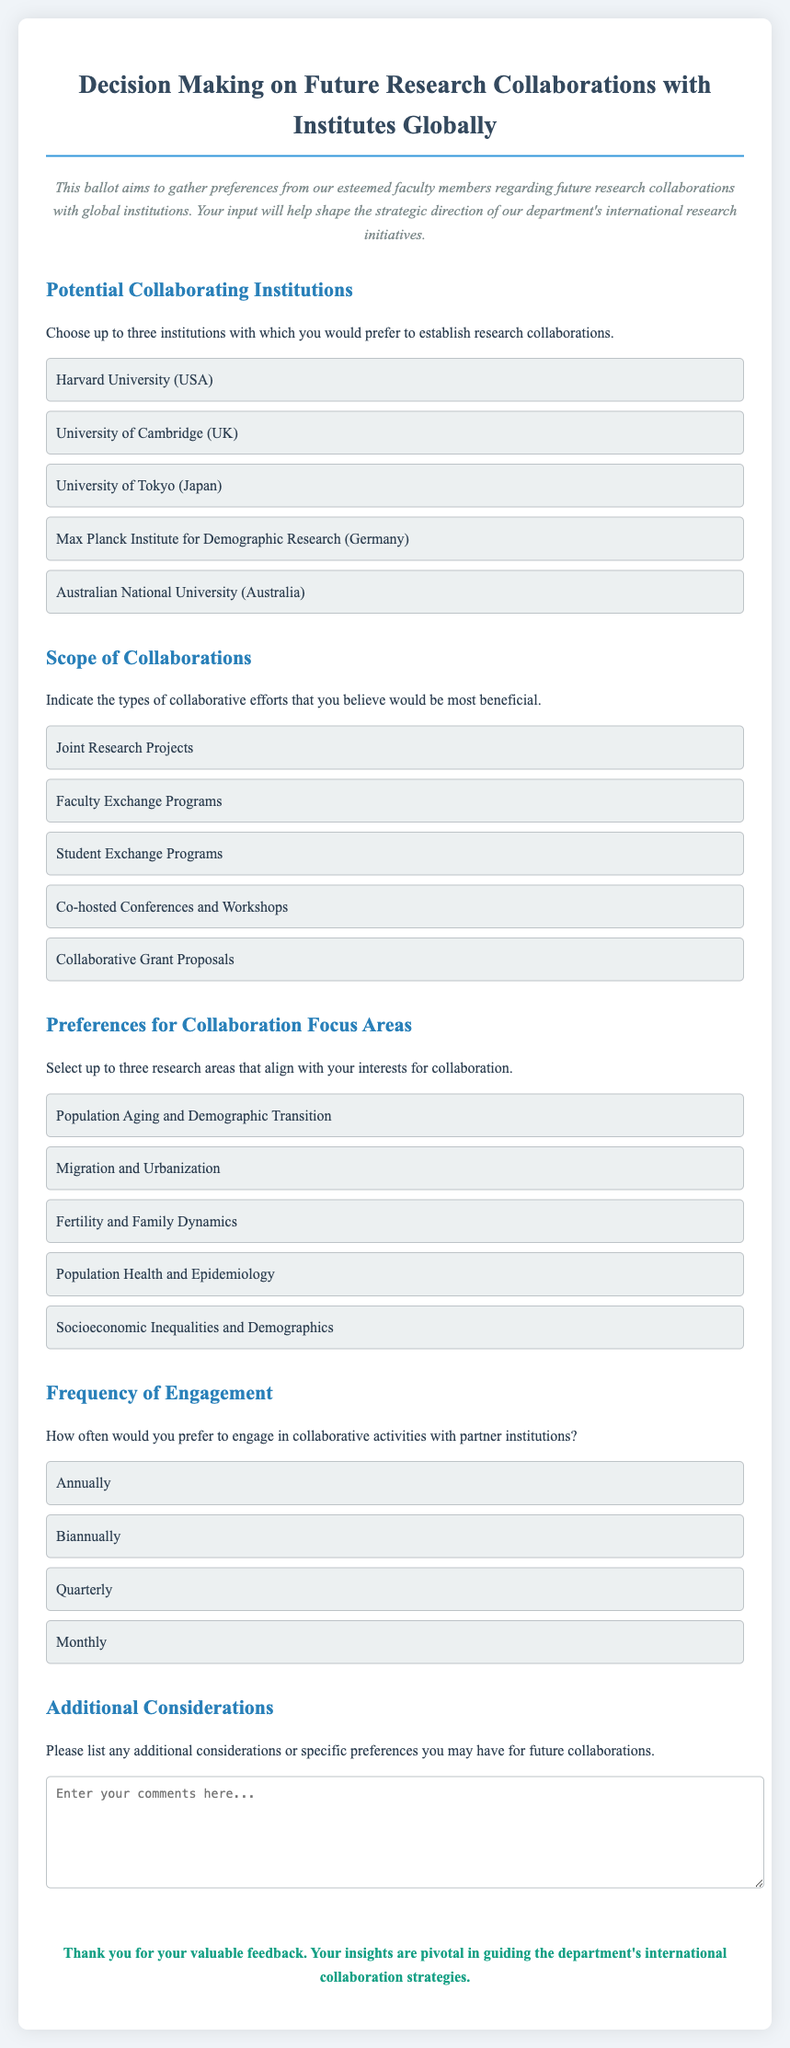What is the title of the ballot? The title is explicitly stated at the beginning of the document, indicating the purpose of the ballot regarding research collaborations.
Answer: Decision Making on Future Research Collaborations with Institutes Globally How many institutions can faculty members choose for collaboration? The document specifies that faculty members can select up to three institutions to express their preference for collaboration.
Answer: Three Which institution is listed as a collaboration option in Japan? The document includes a list of institutions for potential collaboration, one of which is based in Japan.
Answer: University of Tokyo What type of collaborative effort is proposed for co-hosted events? The document discusses various types of collaboration, including specific efforts involving events that can be co-hosted.
Answer: Co-hosted Conferences and Workshops What research area focuses on demographic transitions? Among the research areas listed for faculty collaboration preferences, one is explicitly related to demographic transitions and aging.
Answer: Population Aging and Demographic Transition Which frequency of engagement option is available for faculty preference? The document provides multiple timeframes for how often faculty wish to engage in collaborations, one of which is specified.
Answer: Biannually What is the purpose of the additional considerations section? The document asks faculty to provide any further thoughts, preferences, or specifics regarding future collaborations.
Answer: Additional considerations or specific preferences What color is the background of the ballot? The background color is described in the styling section of the document, affecting the overall aesthetics of the ballot.
Answer: Light gray 